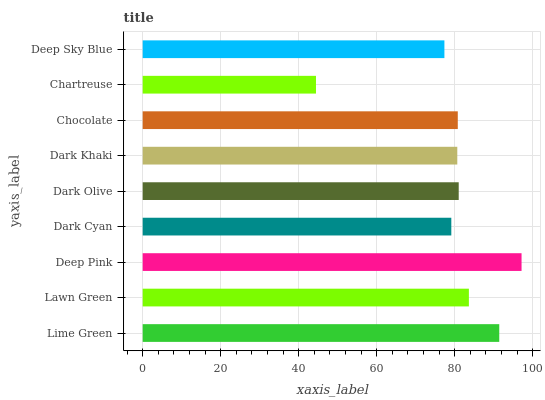Is Chartreuse the minimum?
Answer yes or no. Yes. Is Deep Pink the maximum?
Answer yes or no. Yes. Is Lawn Green the minimum?
Answer yes or no. No. Is Lawn Green the maximum?
Answer yes or no. No. Is Lime Green greater than Lawn Green?
Answer yes or no. Yes. Is Lawn Green less than Lime Green?
Answer yes or no. Yes. Is Lawn Green greater than Lime Green?
Answer yes or no. No. Is Lime Green less than Lawn Green?
Answer yes or no. No. Is Chocolate the high median?
Answer yes or no. Yes. Is Chocolate the low median?
Answer yes or no. Yes. Is Deep Pink the high median?
Answer yes or no. No. Is Lawn Green the low median?
Answer yes or no. No. 